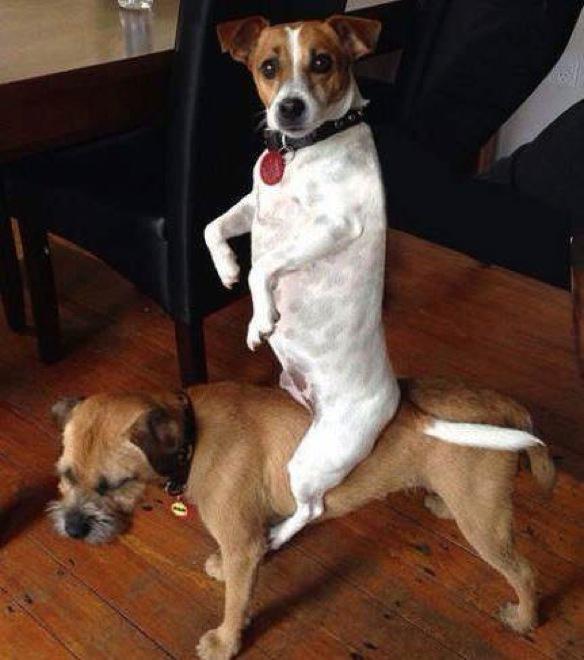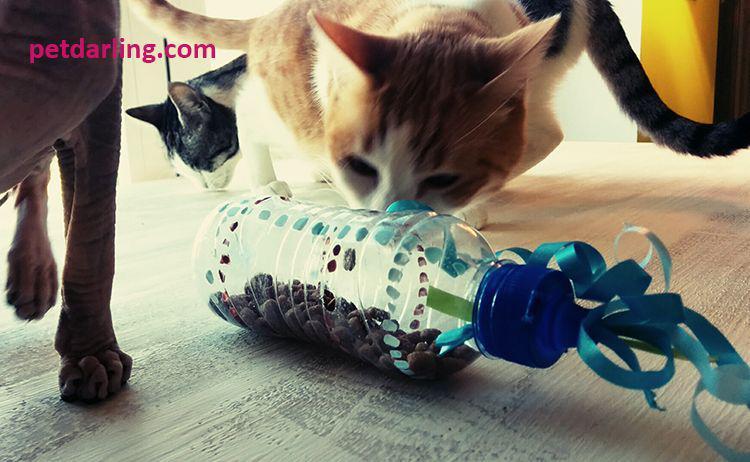The first image is the image on the left, the second image is the image on the right. Assess this claim about the two images: "An image shows a cat crouched behind a bottle trimmed with blue curly ribbon.". Correct or not? Answer yes or no. Yes. The first image is the image on the left, the second image is the image on the right. For the images displayed, is the sentence "A cat is rolling a bottle on the floor in one of the images." factually correct? Answer yes or no. Yes. 